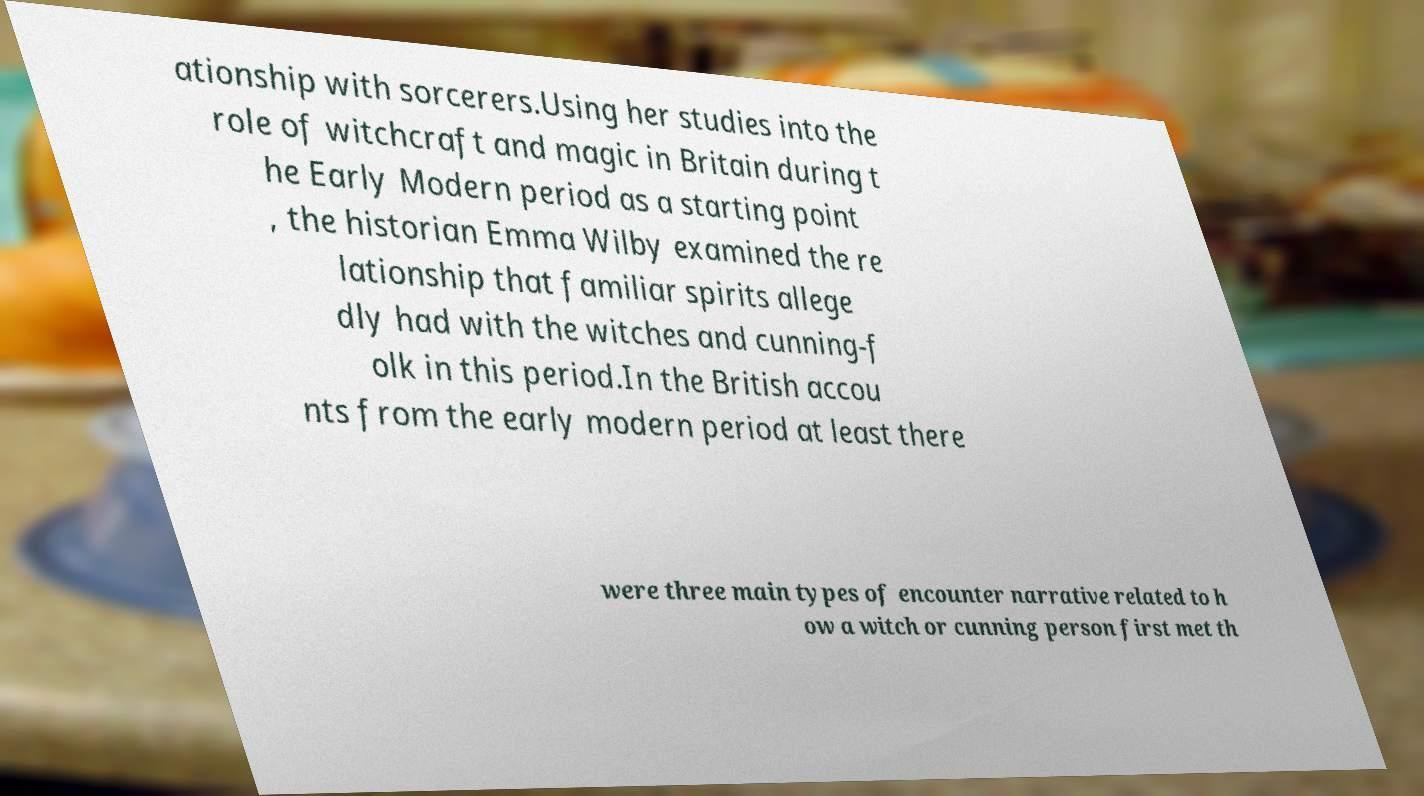Can you read and provide the text displayed in the image?This photo seems to have some interesting text. Can you extract and type it out for me? ationship with sorcerers.Using her studies into the role of witchcraft and magic in Britain during t he Early Modern period as a starting point , the historian Emma Wilby examined the re lationship that familiar spirits allege dly had with the witches and cunning-f olk in this period.In the British accou nts from the early modern period at least there were three main types of encounter narrative related to h ow a witch or cunning person first met th 